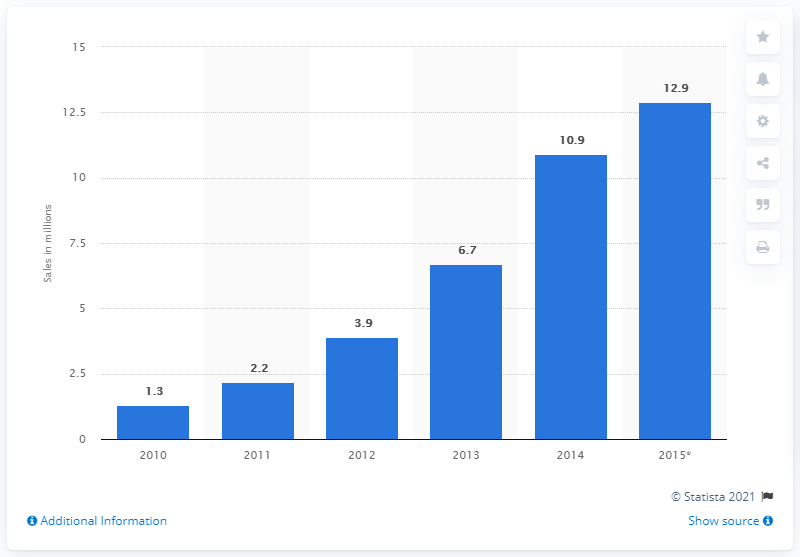Identify some key points in this picture. In 2013, a total of 6.7 units of soundbar speakers were sold worldwide. 